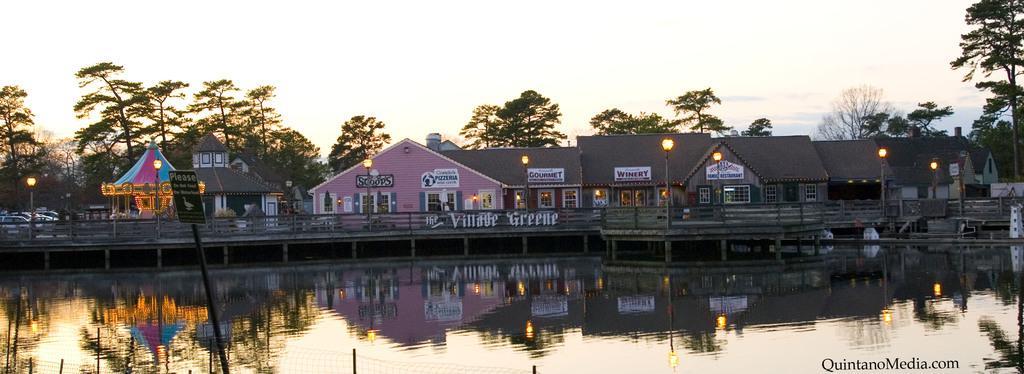Could you give a brief overview of what you see in this image? In this picture we can see the buildings. In front of the building we can see bridge, wooden fencing and street lights. At the bottom we can see the steel fencing & board near to the water. On the left we can see many cars which are parked near to the trees. At the top we can see sky and clouds. In the bottom right corner there is a watermark. On the wall we can see boards and posters. 